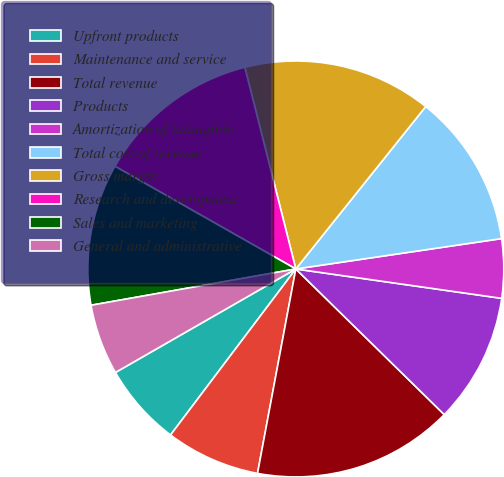Convert chart. <chart><loc_0><loc_0><loc_500><loc_500><pie_chart><fcel>Upfront products<fcel>Maintenance and service<fcel>Total revenue<fcel>Products<fcel>Amortization of intangible<fcel>Total cost of revenue<fcel>Gross margin<fcel>Research and development<fcel>Sales and marketing<fcel>General and administrative<nl><fcel>6.42%<fcel>7.34%<fcel>15.6%<fcel>10.09%<fcel>4.59%<fcel>11.93%<fcel>14.68%<fcel>12.84%<fcel>11.01%<fcel>5.5%<nl></chart> 